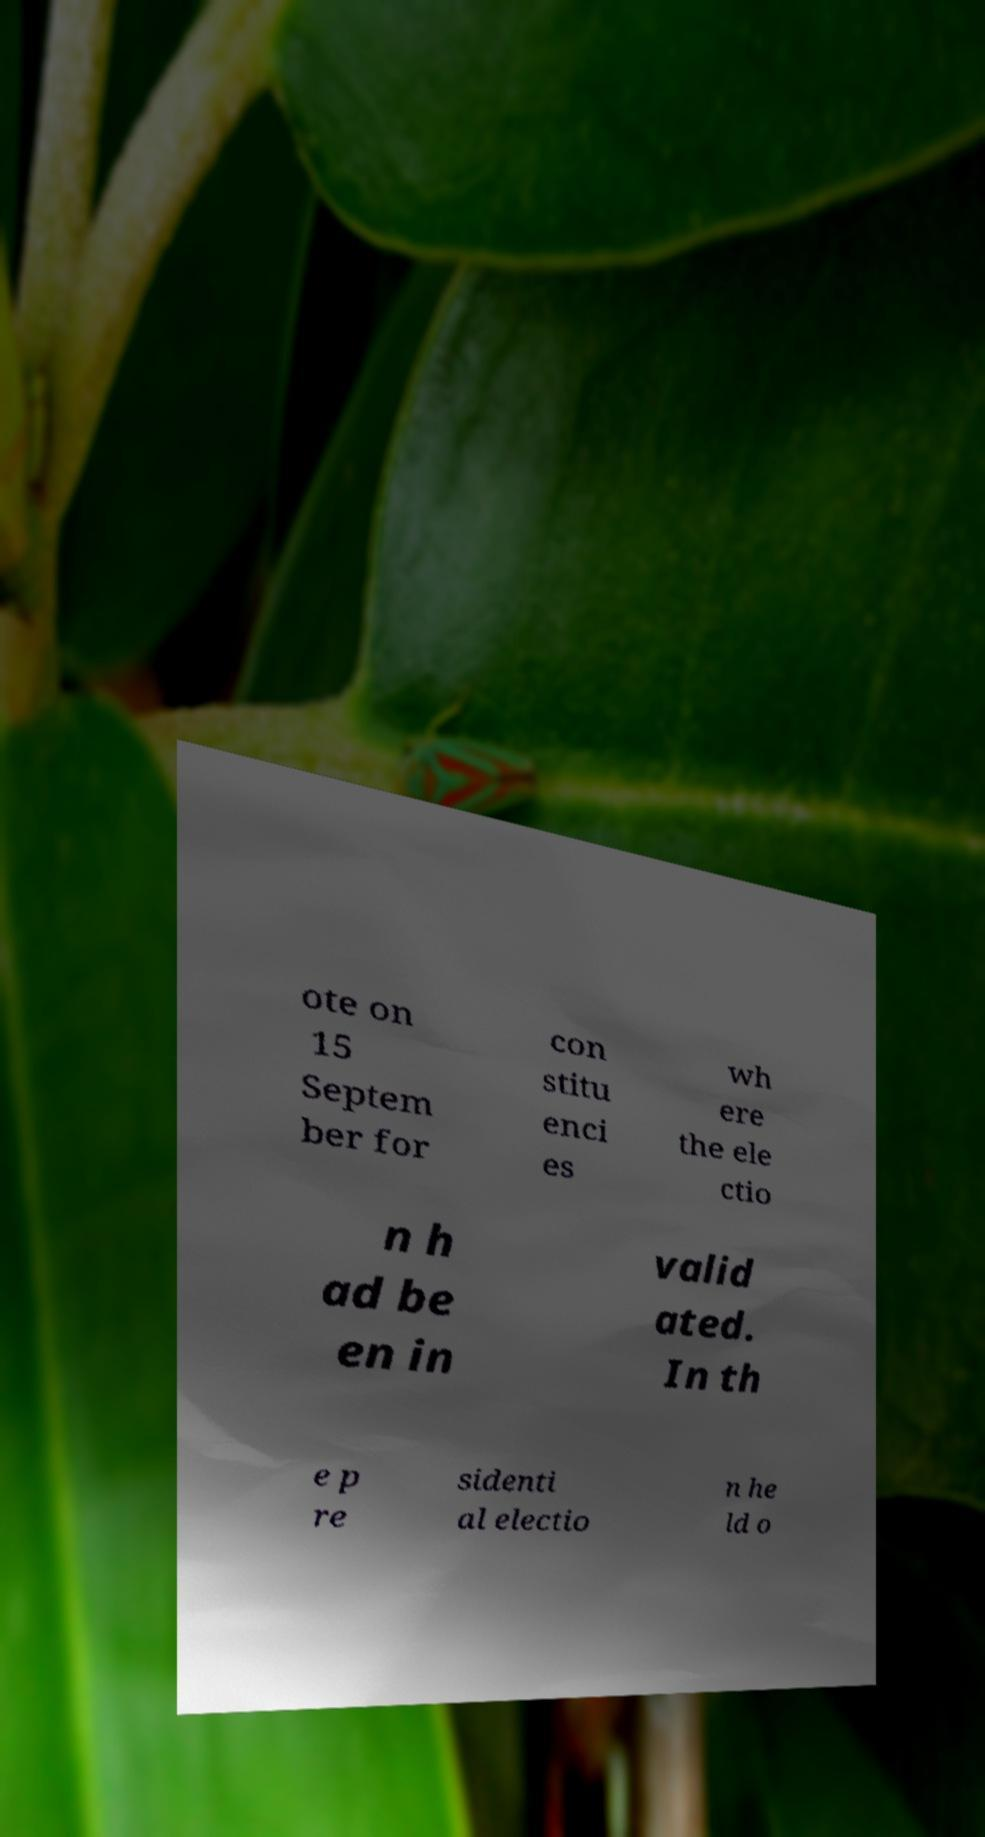Can you read and provide the text displayed in the image?This photo seems to have some interesting text. Can you extract and type it out for me? ote on 15 Septem ber for con stitu enci es wh ere the ele ctio n h ad be en in valid ated. In th e p re sidenti al electio n he ld o 